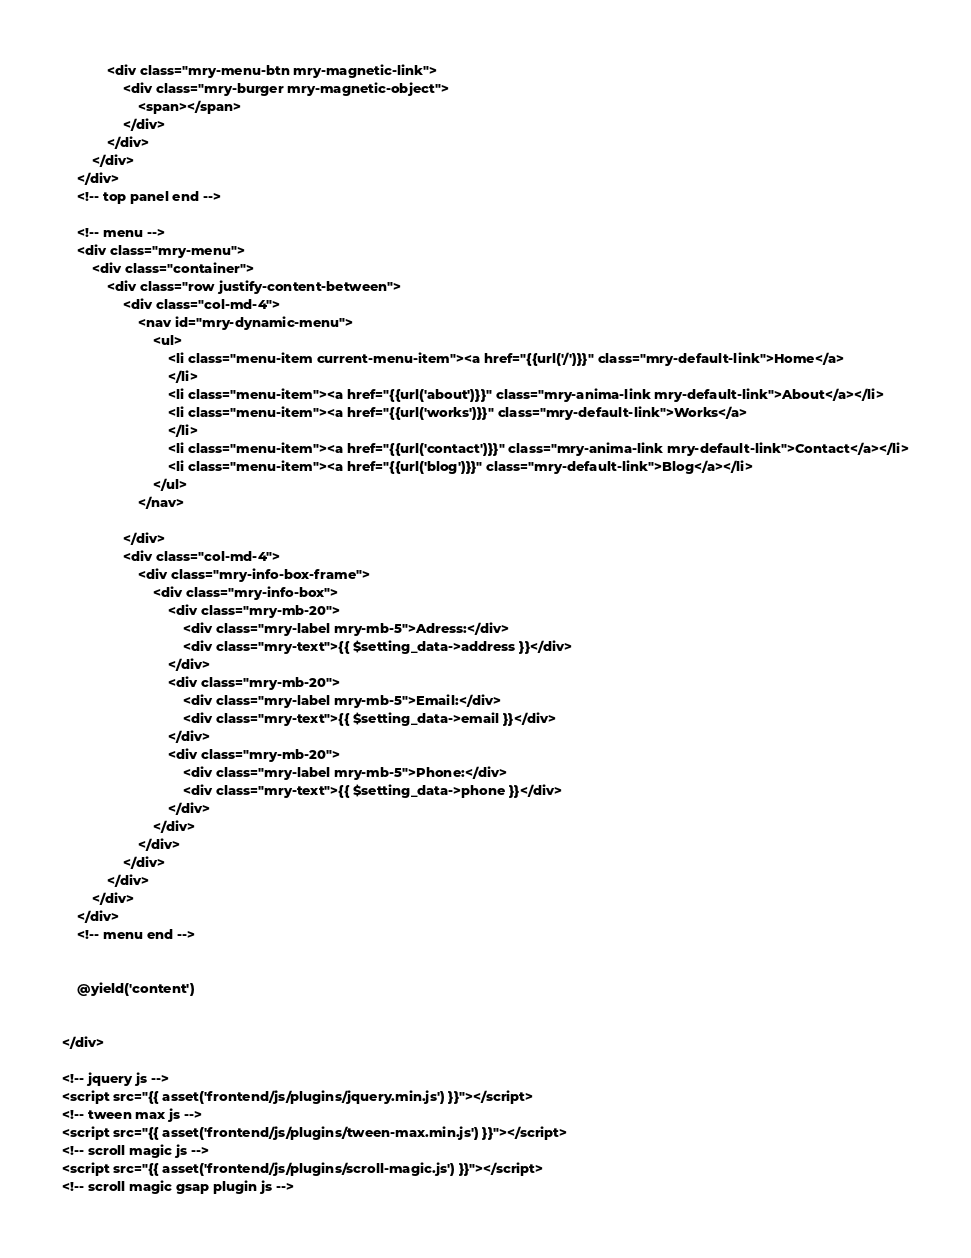Convert code to text. <code><loc_0><loc_0><loc_500><loc_500><_PHP_>			<div class="mry-menu-btn mry-magnetic-link">
				<div class="mry-burger mry-magnetic-object">
					<span></span>
				</div>
			</div>
		</div>
	</div>
	<!-- top panel end -->

	<!-- menu -->
	<div class="mry-menu">
		<div class="container">
			<div class="row justify-content-between">
				<div class="col-md-4">
					<nav id="mry-dynamic-menu">
						<ul>
							<li class="menu-item current-menu-item"><a href="{{url('/')}}" class="mry-default-link">Home</a>
							</li>
							<li class="menu-item"><a href="{{url('about')}}" class="mry-anima-link mry-default-link">About</a></li>
							<li class="menu-item"><a href="{{url('works')}}" class="mry-default-link">Works</a>
							</li>
							<li class="menu-item"><a href="{{url('contact')}}" class="mry-anima-link mry-default-link">Contact</a></li>
							<li class="menu-item"><a href="{{url('blog')}}" class="mry-default-link">Blog</a></li>
						</ul>
					</nav>

				</div>
				<div class="col-md-4">
					<div class="mry-info-box-frame">
						<div class="mry-info-box">
							<div class="mry-mb-20">
								<div class="mry-label mry-mb-5">Adress:</div>
								<div class="mry-text">{{ $setting_data->address }}</div>
							</div>
							<div class="mry-mb-20">
								<div class="mry-label mry-mb-5">Email:</div>
								<div class="mry-text">{{ $setting_data->email }}</div>
							</div>
							<div class="mry-mb-20">
								<div class="mry-label mry-mb-5">Phone:</div>
								<div class="mry-text">{{ $setting_data->phone }}</div>
							</div>
						</div>
					</div>
				</div>
			</div>
		</div>
	</div>
	<!-- menu end -->


	@yield('content')


</div>

<!-- jquery js -->
<script src="{{ asset('frontend/js/plugins/jquery.min.js') }}"></script>
<!-- tween max js -->
<script src="{{ asset('frontend/js/plugins/tween-max.min.js') }}"></script>
<!-- scroll magic js -->
<script src="{{ asset('frontend/js/plugins/scroll-magic.js') }}"></script>
<!-- scroll magic gsap plugin js --></code> 